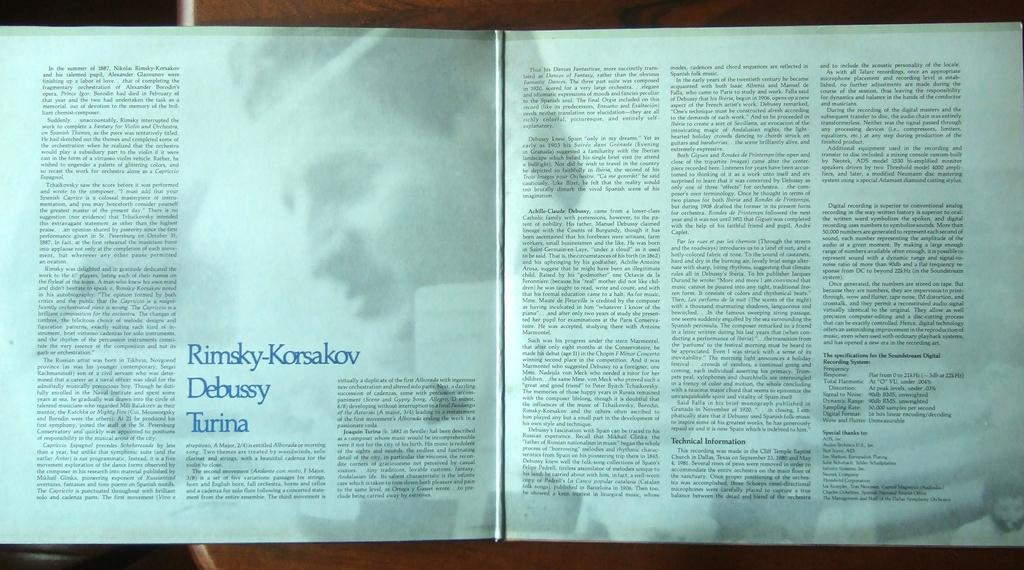<image>
Write a terse but informative summary of the picture. An open book with the text Rimsky Korsalov Debusy Turina on the middle lower section. 